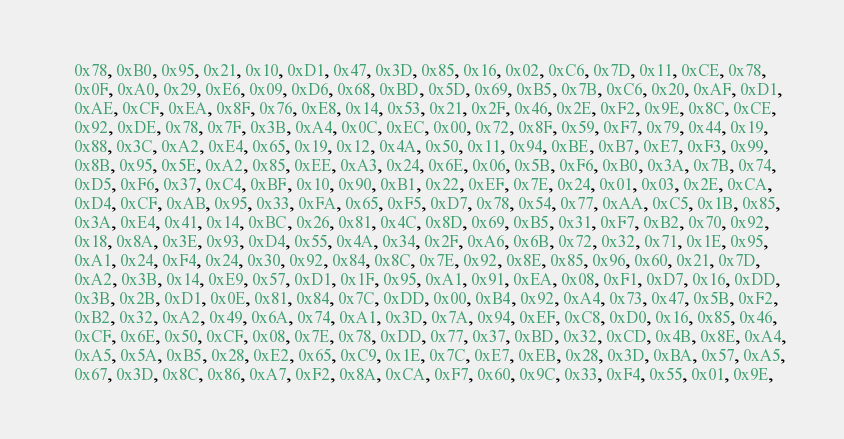Convert code to text. <code><loc_0><loc_0><loc_500><loc_500><_C_>    0x78, 0xB0, 0x95, 0x21, 0x10, 0xD1, 0x47, 0x3D, 0x85, 0x16, 0x02, 0xC6, 0x7D, 0x11, 0xCE, 0x78,
    0x0F, 0xA0, 0x29, 0xE6, 0x09, 0xD6, 0x68, 0xBD, 0x5D, 0x69, 0xB5, 0x7B, 0xC6, 0x20, 0xAF, 0xD1,
    0xAE, 0xCF, 0xEA, 0x8F, 0x76, 0xE8, 0x14, 0x53, 0x21, 0x2F, 0x46, 0x2E, 0xF2, 0x9E, 0x8C, 0xCE,
    0x92, 0xDE, 0x78, 0x7F, 0x3B, 0xA4, 0x0C, 0xEC, 0x00, 0x72, 0x8F, 0x59, 0xF7, 0x79, 0x44, 0x19,
    0x88, 0x3C, 0xA2, 0xE4, 0x65, 0x19, 0x12, 0x4A, 0x50, 0x11, 0x94, 0xBE, 0xB7, 0xE7, 0xF3, 0x99,
    0x8B, 0x95, 0x5E, 0xA2, 0x85, 0xEE, 0xA3, 0x24, 0x6E, 0x06, 0x5B, 0xF6, 0xB0, 0x3A, 0x7B, 0x74,
    0xD5, 0xF6, 0x37, 0xC4, 0xBF, 0x10, 0x90, 0xB1, 0x22, 0xEF, 0x7E, 0x24, 0x01, 0x03, 0x2E, 0xCA,
    0xD4, 0xCF, 0xAB, 0x95, 0x33, 0xFA, 0x65, 0xF5, 0xD7, 0x78, 0x54, 0x77, 0xAA, 0xC5, 0x1B, 0x85,
    0x3A, 0xE4, 0x41, 0x14, 0xBC, 0x26, 0x81, 0x4C, 0x8D, 0x69, 0xB5, 0x31, 0xF7, 0xB2, 0x70, 0x92,
    0x18, 0x8A, 0x3E, 0x93, 0xD4, 0x55, 0x4A, 0x34, 0x2F, 0xA6, 0x6B, 0x72, 0x32, 0x71, 0x1E, 0x95,
    0xA1, 0x24, 0xF4, 0x24, 0x30, 0x92, 0x84, 0x8C, 0x7E, 0x92, 0x8E, 0x85, 0x96, 0x60, 0x21, 0x7D,
    0xA2, 0x3B, 0x14, 0xE9, 0x57, 0xD1, 0x1F, 0x95, 0xA1, 0x91, 0xEA, 0x08, 0xF1, 0xD7, 0x16, 0xDD,
    0x3B, 0x2B, 0xD1, 0x0E, 0x81, 0x84, 0x7C, 0xDD, 0x00, 0xB4, 0x92, 0xA4, 0x73, 0x47, 0x5B, 0xF2,
    0xB2, 0x32, 0xA2, 0x49, 0x6A, 0x74, 0xA1, 0x3D, 0x7A, 0x94, 0xEF, 0xC8, 0xD0, 0x16, 0x85, 0x46,
    0xCF, 0x6E, 0x50, 0xCF, 0x08, 0x7E, 0x78, 0xDD, 0x77, 0x37, 0xBD, 0x32, 0xCD, 0x4B, 0x8E, 0xA4,
    0xA5, 0x5A, 0xB5, 0x28, 0xE2, 0x65, 0xC9, 0x1E, 0x7C, 0xE7, 0xEB, 0x28, 0x3D, 0xBA, 0x57, 0xA5,
    0x67, 0x3D, 0x8C, 0x86, 0xA7, 0xF2, 0x8A, 0xCA, 0xF7, 0x60, 0x9C, 0x33, 0xF4, 0x55, 0x01, 0x9E,</code> 